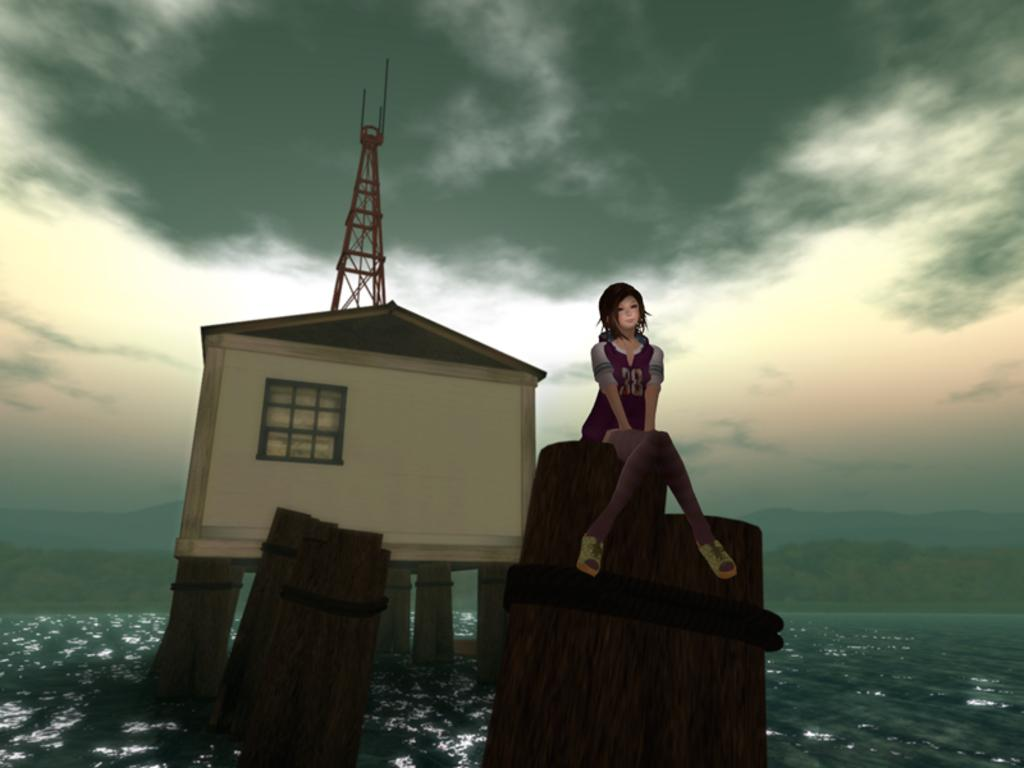What type of picture is in the image? The image contains an animated picture. Can you describe the person in the image? There is a person in the image. What structure is present in the image? There is a house in the image. What objects are made of wood in the image? There are wooden logs in the image. What is the tower's location in the image? The tower is on the water in the image. What can be seen in the background of the image? Trees and the sky are visible in the background of the image. What type of locket is the mother wearing in the image? There is no mother or locket present in the image. How many chairs are visible in the image? There are no chairs mentioned or visible in the image. 